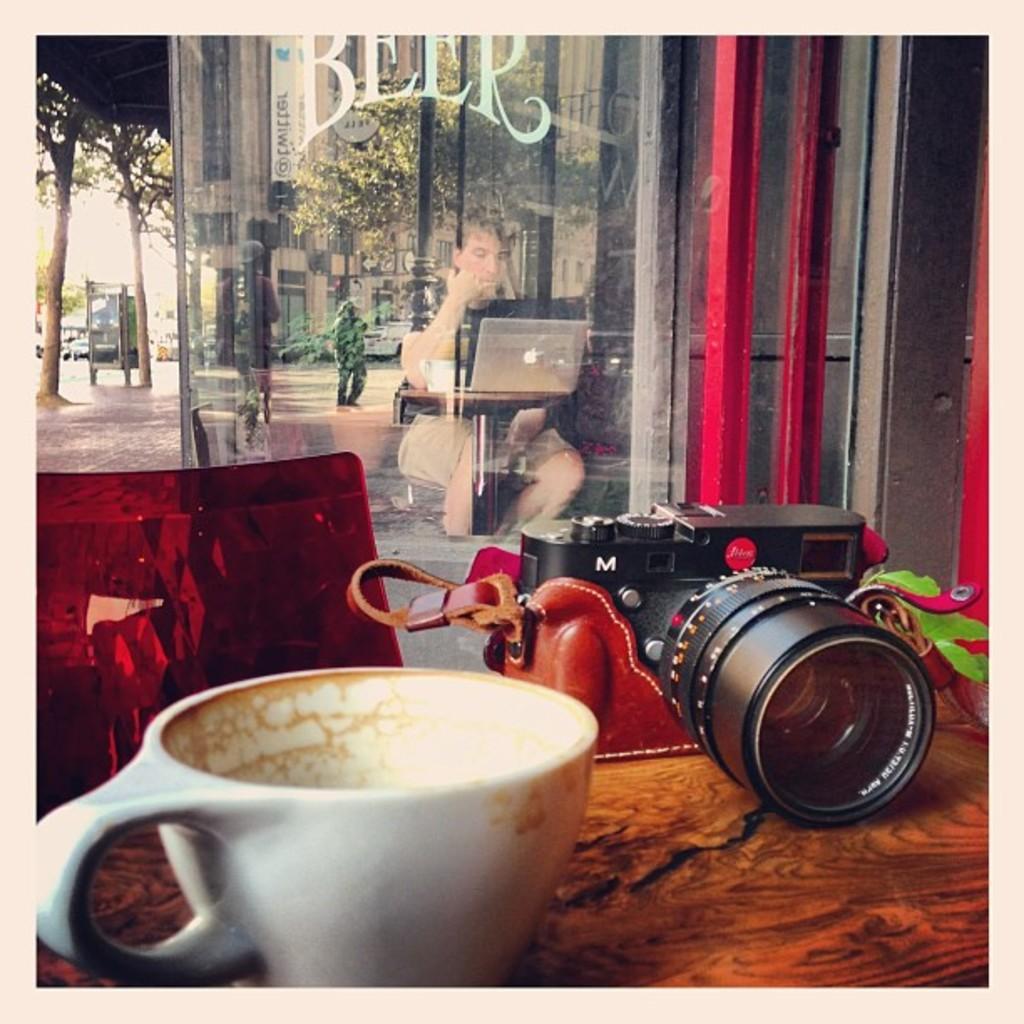Please provide a concise description of this image. At the bottom there is a table on which a teacup and camera are placed. Behind the table there is a chair. In the background there is a glass on which I can see the reflection of a person sitting and looking into the laptop which is placed on a table and also I can see few people on the ground, building, trees and poles. On the left side of the image there are few trees and also I can see vehicles. 